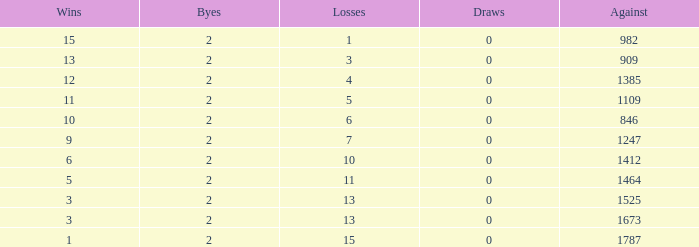What is the number listed under against when there were less than 13 losses and less than 2 byes? 0.0. 